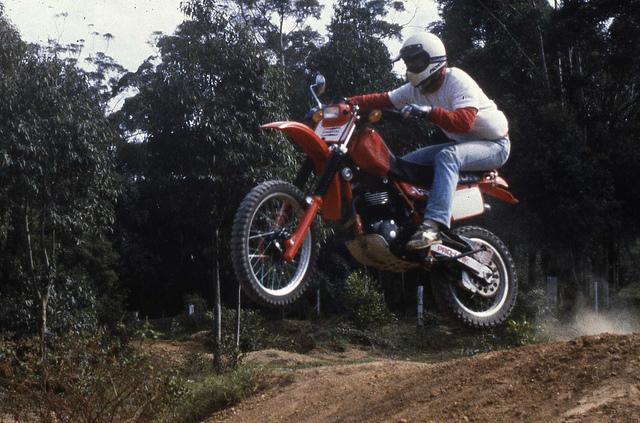What sport is this?
Keep it brief. Motocross. Will this person have a sore butt when he lands?
Write a very short answer. Yes. What pants is the person wearing?
Concise answer only. Jeans. 